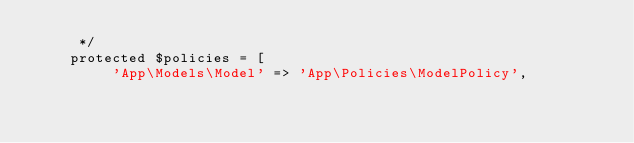Convert code to text. <code><loc_0><loc_0><loc_500><loc_500><_PHP_>     */
    protected $policies = [
         'App\Models\Model' => 'App\Policies\ModelPolicy',</code> 